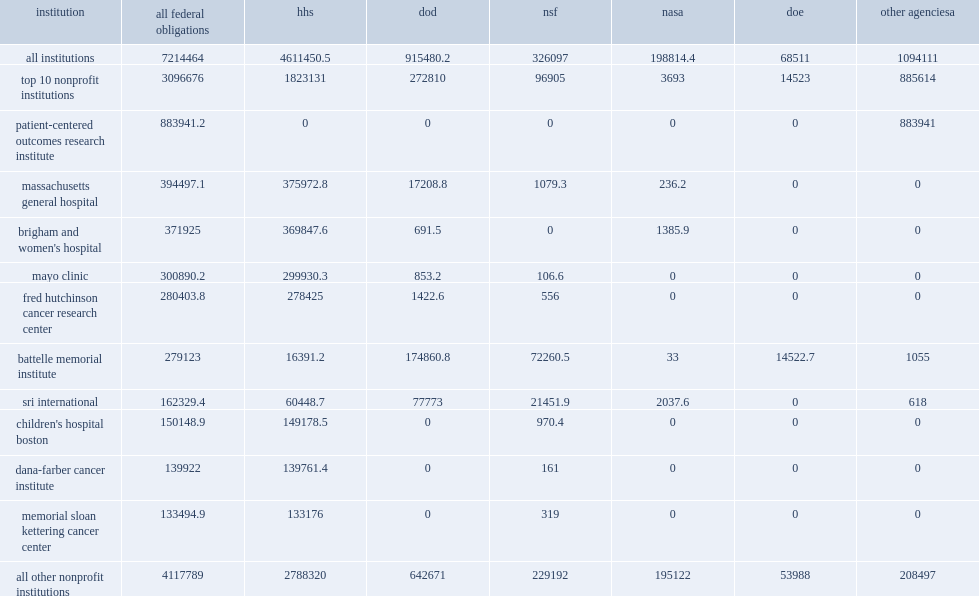During fy 2017, how many thousand dollars did federal agencies obligate in r&d? 7214464.0. How many thousand dollars did the patient-centered outcomes research institute receive the most in federal funds for r&d and r&d plant? 883941.2. 